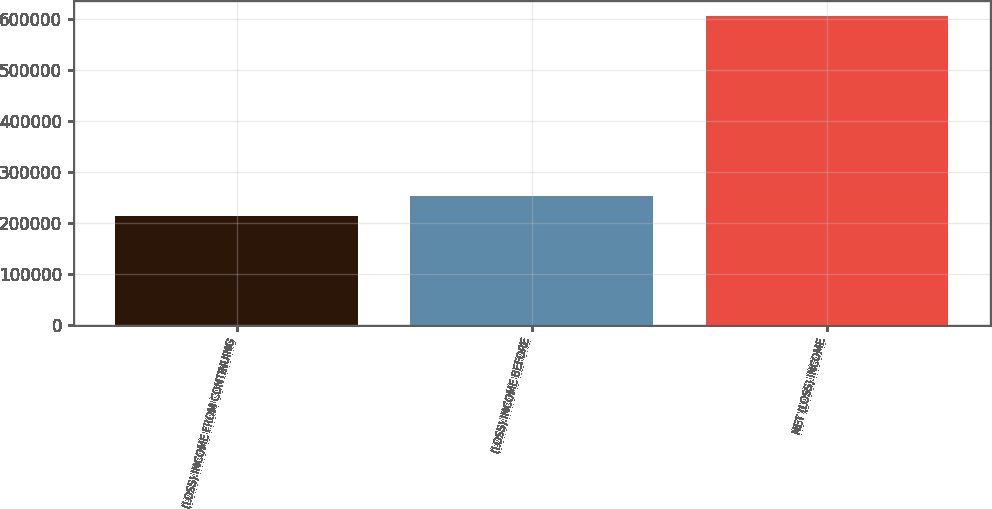Convert chart. <chart><loc_0><loc_0><loc_500><loc_500><bar_chart><fcel>(LOSS) INCOME FROM CONTINUING<fcel>(LOSS) INCOME BEFORE<fcel>NET (LOSS) INCOME<nl><fcel>214715<fcel>253875<fcel>606319<nl></chart> 